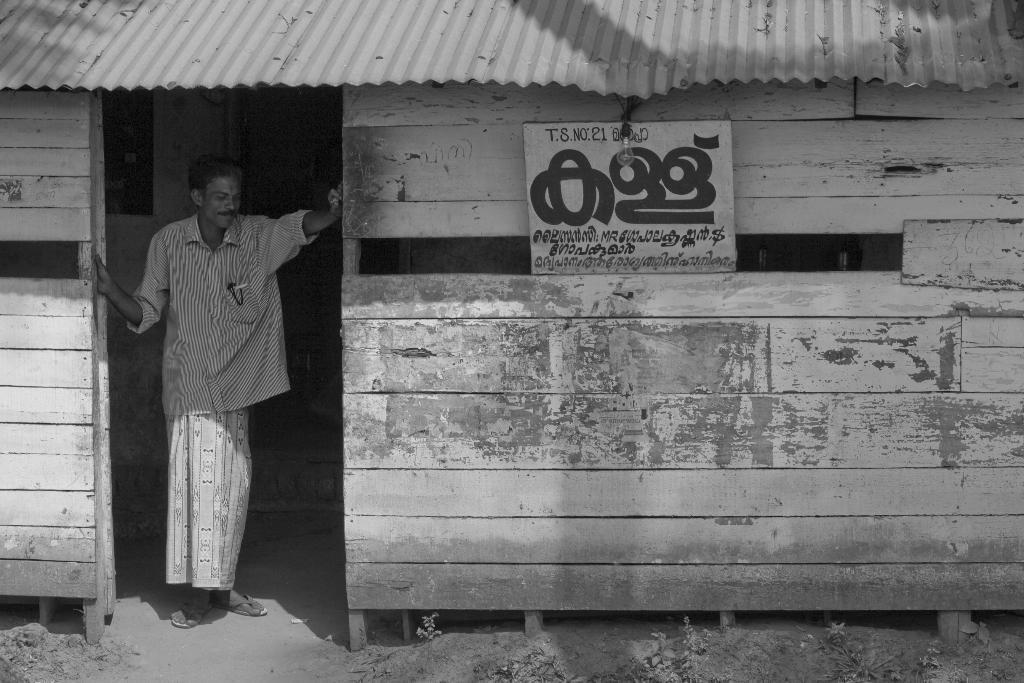Could you give a brief overview of what you see in this image? This is a black and white image. We can see a man standing in the house and there is a board attached to the wall. There is a bulb hanging. At the top of the image, there are metal sheets. 